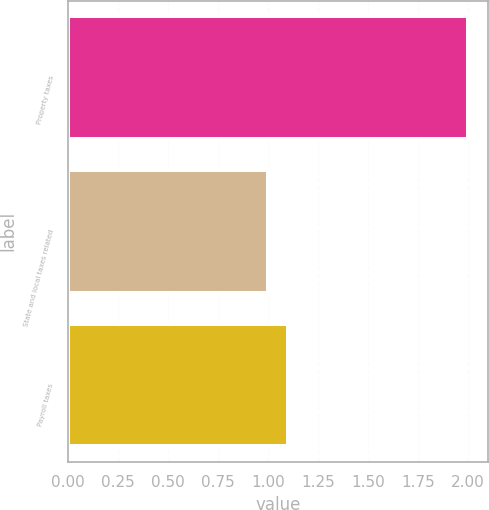Convert chart to OTSL. <chart><loc_0><loc_0><loc_500><loc_500><bar_chart><fcel>Property taxes<fcel>State and local taxes related<fcel>Payroll taxes<nl><fcel>2<fcel>1<fcel>1.1<nl></chart> 